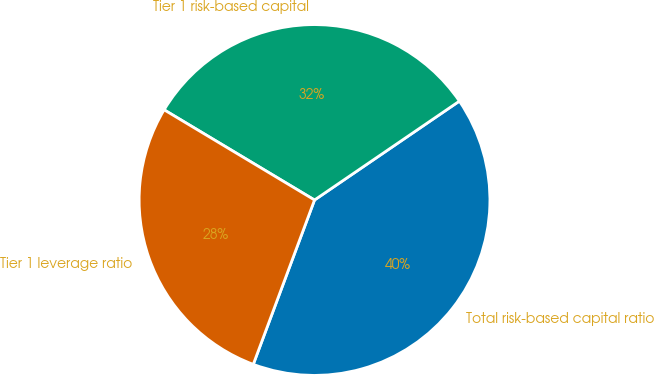Convert chart. <chart><loc_0><loc_0><loc_500><loc_500><pie_chart><fcel>Total risk-based capital ratio<fcel>Tier 1 risk-based capital<fcel>Tier 1 leverage ratio<nl><fcel>40.21%<fcel>31.87%<fcel>27.92%<nl></chart> 